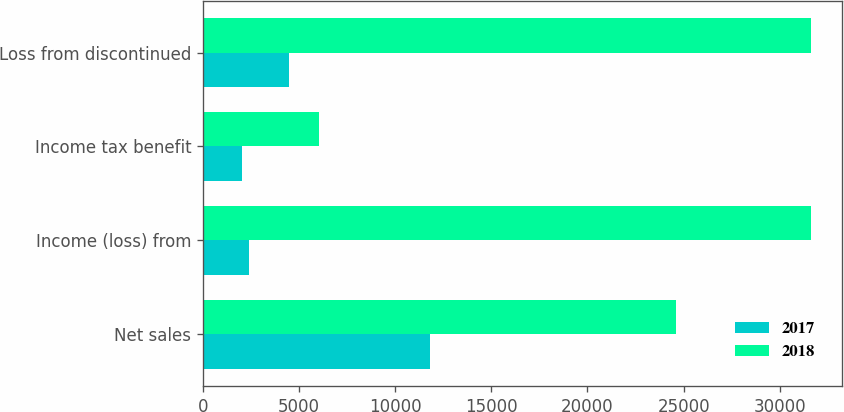<chart> <loc_0><loc_0><loc_500><loc_500><stacked_bar_chart><ecel><fcel>Net sales<fcel>Income (loss) from<fcel>Income tax benefit<fcel>Loss from discontinued<nl><fcel>2017<fcel>11808<fcel>2370<fcel>2016<fcel>4474<nl><fcel>2018<fcel>24590<fcel>31654<fcel>6055<fcel>31654<nl></chart> 